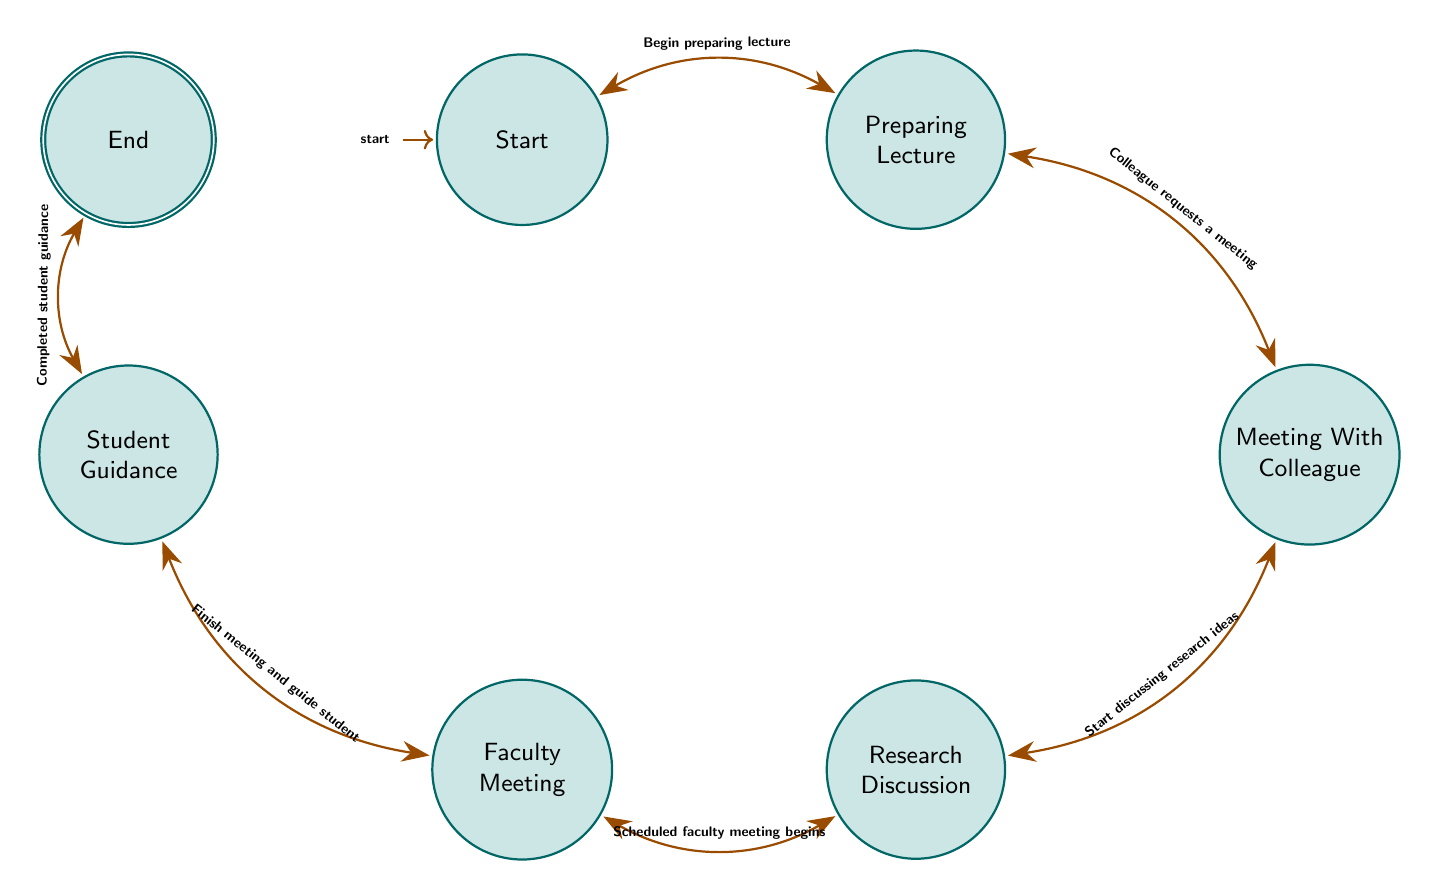What is the initial state of the diagram? The initial state is labeled as "Start." It represents where a professor has not yet engaged in any interactions.
Answer: Start How many states are in the diagram? By counting the states listed, we find there are seven distinct states: Start, Preparing Lecture, Meeting With Colleague, Research Discussion, Faculty Meeting, Student Guidance, and End.
Answer: 7 What action leads to the "Meeting With Colleague" state? The transition from "Preparing Lecture" to "Meeting With Colleague" occurs when a colleague requests a meeting. This specific action defines the relationship between these two states.
Answer: Colleague requests a meeting What occurs after the "Research Discussion" state? Following "Research Discussion," the next action is the beginning of the scheduled faculty meeting, which leads the professor into the "Faculty Meeting" state.
Answer: Faculty Meeting Which state does the "Student Guidance" lead to? After "Student Guidance" is the "End" state, resulting from the action of completing guidance for a student, indicating that interactions for the day are finished.
Answer: End How many transitions are present in the diagram? By reviewing the list of transitions provided, we note there are six transitions that connect the states in a sequential manner.
Answer: 6 What is the final state in the interaction flow? The final or accepting state is called "End," representing the conclusion of the professor's interactions for the day.
Answer: End What action is required to move from "Faculty Meeting" to "Student Guidance"? The transition between these two states happens after the faculty meeting is finished, prompting the professor to guide a student thereafter.
Answer: Finish meeting and guide student What happens if a colleague does not request a meeting while preparing a lecture? If there is no request for a meeting, the professor would remain in the "Preparing Lecture" state, continuing to prepare lecture materials without progression in interactions.
Answer: Remain in Preparing Lecture 